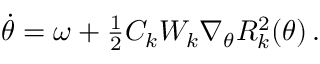Convert formula to latex. <formula><loc_0><loc_0><loc_500><loc_500>\begin{array} { r } { \ D o t { \theta } = \omega + \frac { 1 } { 2 } C _ { k } W _ { k } \nabla _ { \theta } R _ { k } ^ { 2 } ( \theta ) \, . } \end{array}</formula> 